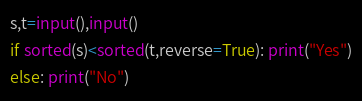<code> <loc_0><loc_0><loc_500><loc_500><_Python_>s,t=input(),input()
if sorted(s)<sorted(t,reverse=True): print("Yes")
else: print("No")</code> 